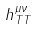Convert formula to latex. <formula><loc_0><loc_0><loc_500><loc_500>h _ { T T } ^ { \mu \nu }</formula> 